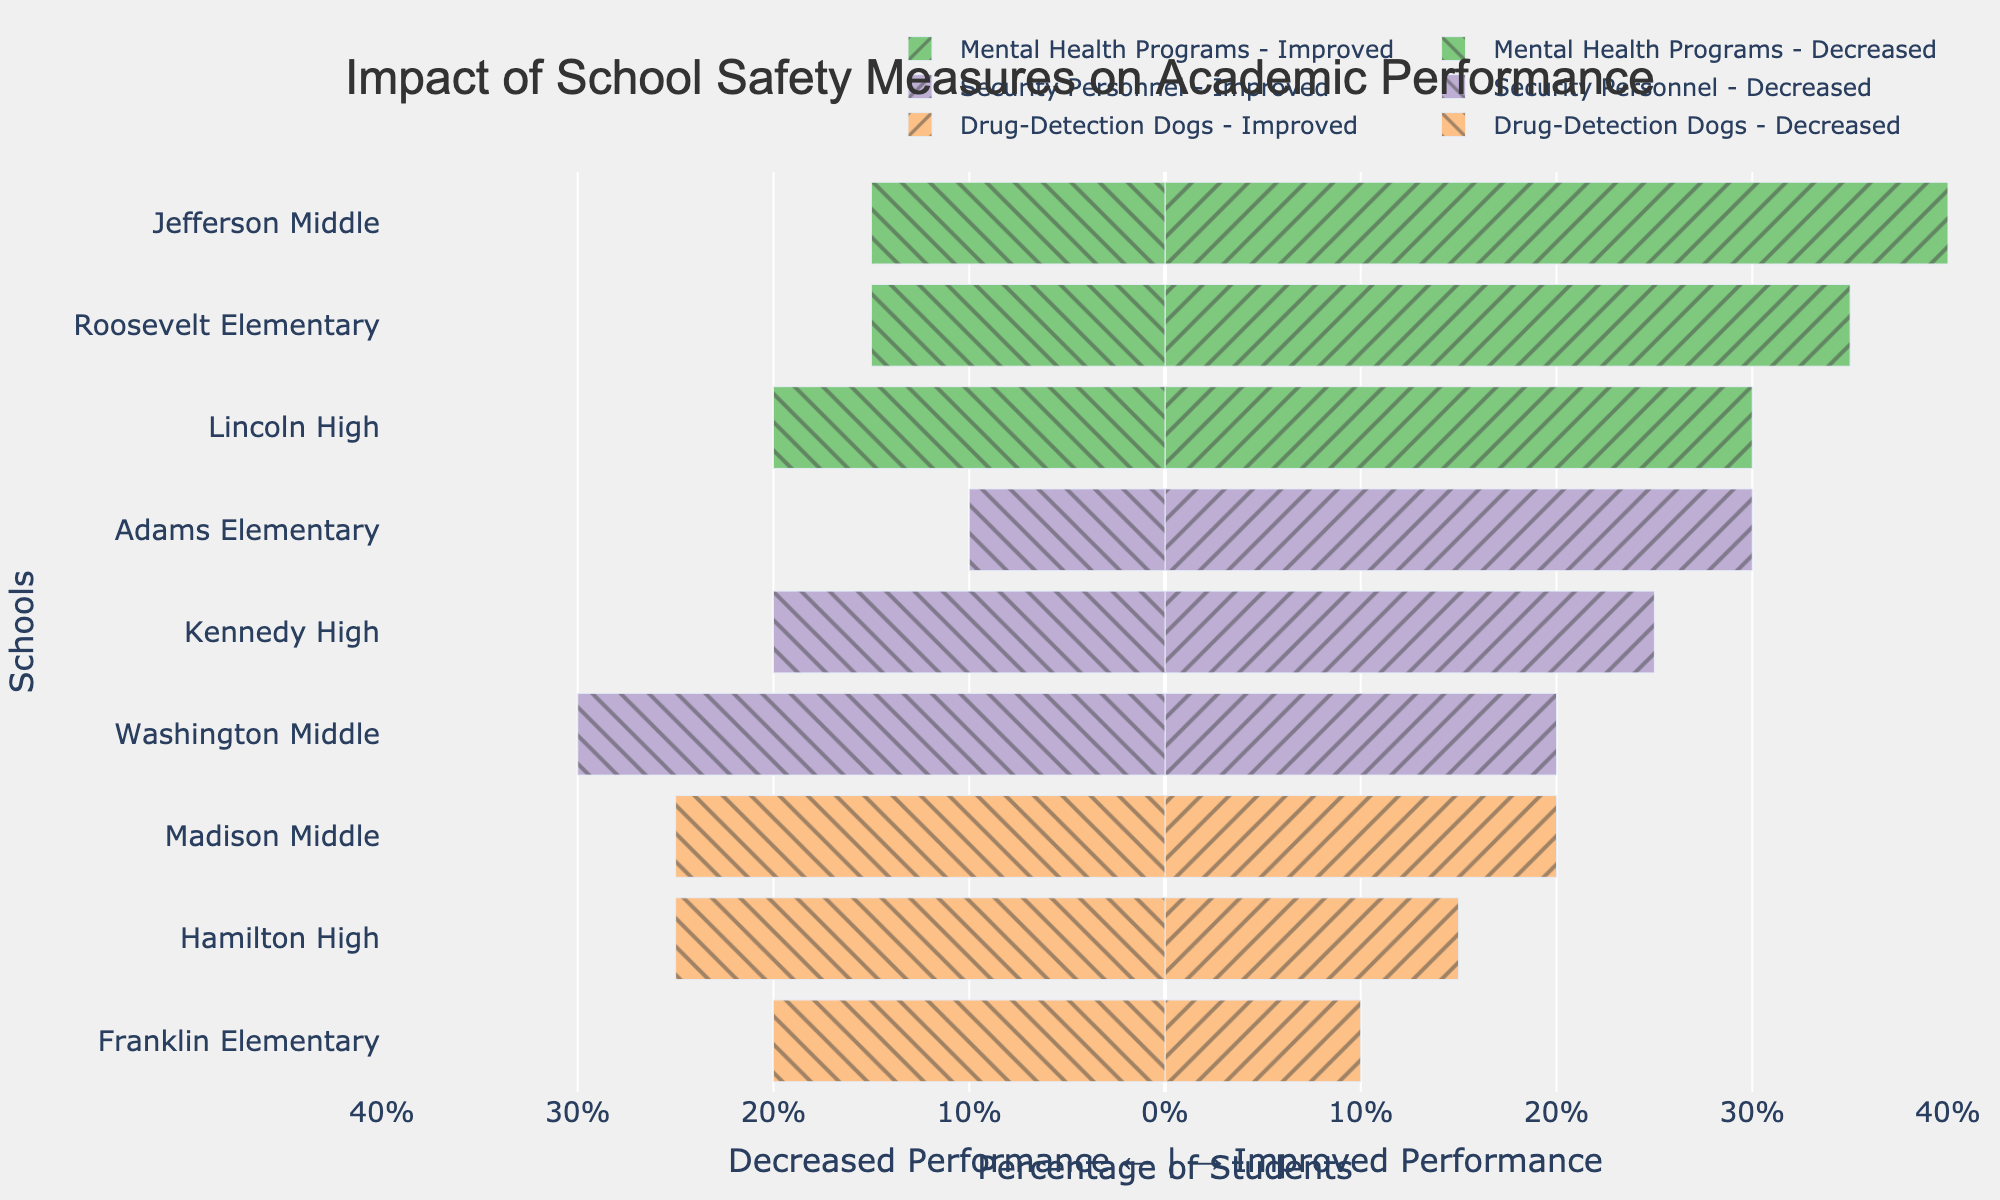What measure has the highest percentage of improved performance at Roosevelt Elementary? From the chart, we look for Roosevelt Elementary and compare the heights of the bars representing "Improved Performance" for each measure. The tallest bar is for Mental Health Programs, indicating the highest percentage of improved performance.
Answer: Mental Health Programs Which school shows the largest decrease in performance with drug-detection dogs? Identify the segment labeled "Drug-Detection Dogs" and look at the negative bars representing the decrease in performance. Locate the bar with the largest width (most leftward). For drug-detection dogs, Madison Middle and Hamilton High both have a 25% decrease, which are the largest.
Answer: Madison Middle and Hamilton High What is the average percentage of improved performance for schools with security personnel? First, sum the percentages of improved performance for each school under "Security Personnel": 25 (Kennedy High) + 20 (Washington Middle) + 30 (Adams Elementary). Next, divide the sum by the number of schools (3). (25+20+30)/3 = 25.
Answer: 25 Compare the effect of Mental Health Programs and Drug-Detection Dogs on improved performance at Jefferson Middle. Which has a higher percentage and by how much? Identify the percentages for improved performance for both measures at Jefferson Middle: Mental Health Programs (40%) and Drug-Detection Dogs (20%). Compare them: 40% is higher by 40-20 = 20%.
Answer: Mental Health Programs, by 20% Which safety measure has the least impact on decreasing performance at Adams Elementary? Look at Adams Elementary and compare the negative bars representing decreases for each measure. The smallest bar for Adams Elementary is under "Security Personnel" with a 10% decrease.
Answer: Security Personnel What's the total combined percentage of no effect for schools with Mental Health Programs? Add the percentages of no effect for all schools using Mental Health Programs: 50 (Lincoln High) + 45 (Jefferson Middle) + 50 (Roosevelt Elementary). The sum is 50+45+50=145.
Answer: 145 Which school has the most significant disparity between improved and decreased performance for Mental Health Programs? Compare the difference between improved and decreased performance for each school with Mental Health Programs. Calculate the differences: Lincoln High (30-20=10), Jefferson Middle (40-15=25), Roosevelt Elementary (35-15=20). The largest disparity is at Jefferson Middle at 25%.
Answer: Jefferson Middle What is the overall trend in the impact of Drug-Detection Dogs on academic performance? By observing the general direction and length of the bars corresponding to Drug-Detection Dogs, we see that the negative (decreased performance) bars tend to be longer while the positive (improved performance) bars are shorter. This indicates a trend of more schools experiencing a decrease or no effect rather than an improvement.
Answer: More schools experience a decrease or no effect Compare the no effect percentages between Security Personnel at Kennedy High and Washington Middle. Which school has a higher percentage? Look at the bars for no effect at Kennedy High (55%) and Washington Middle (50%). Compare them to see which is higher. Kennedy High's no effect percentage is higher.
Answer: Kennedy High Which measure shows the least variability in its impact on improved and decreased performance across all schools? Variability can be inferred by the uniformity in the lengths of the bars for improved and decreased performance across schools. Mental Health Programs have more consistent bar lengths in both directions compared to the other measures.
Answer: Mental Health Programs 